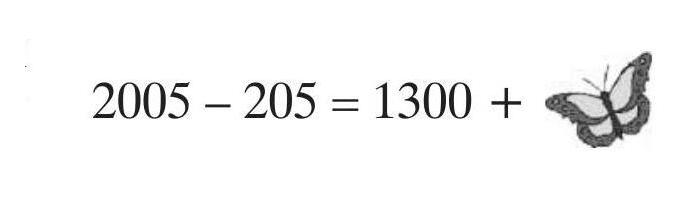Can you explain why the calculation ends on that specific number despite appearing incomplete? The calculation sequence presents a basic subtraction where 2005 minus 205 equals 1300. The specific configuration with the butterfly suggests an illustrative way to engage with basic arithmetic, drawing attention to part of the sequence, which is 500, aiming to prompt further curiosity or examination of basic subtraction concepts. 